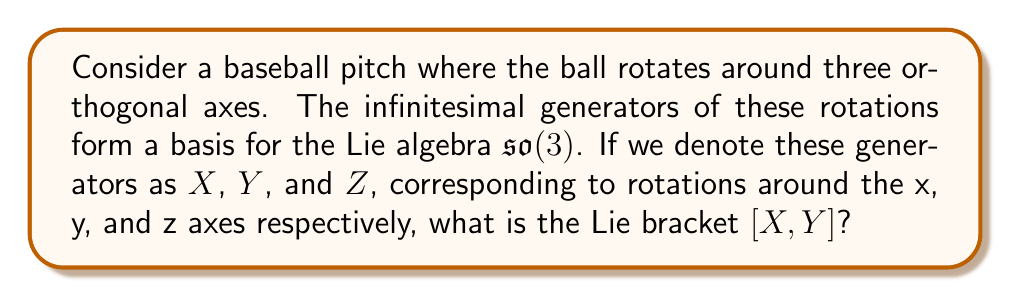Could you help me with this problem? Let's approach this step-by-step:

1) First, recall that for $\mathfrak{so}(3)$, the Lie algebra of 3D rotations, the generators are:

   $$X = \begin{pmatrix}
   0 & 0 & 0 \\
   0 & 0 & -1 \\
   0 & 1 & 0
   \end{pmatrix}, 
   Y = \begin{pmatrix}
   0 & 0 & 1 \\
   0 & 0 & 0 \\
   -1 & 0 & 0
   \end{pmatrix}, 
   Z = \begin{pmatrix}
   0 & -1 & 0 \\
   1 & 0 & 0 \\
   0 & 0 & 0
   \end{pmatrix}$$

2) The Lie bracket $[X,Y]$ is defined as $XY - YX$.

3) Let's compute $XY$:
   $$XY = \begin{pmatrix}
   0 & 0 & 0 \\
   0 & 0 & -1 \\
   0 & 1 & 0
   \end{pmatrix}
   \begin{pmatrix}
   0 & 0 & 1 \\
   0 & 0 & 0 \\
   -1 & 0 & 0
   \end{pmatrix} = 
   \begin{pmatrix}
   0 & 0 & 0 \\
   1 & 0 & 0 \\
   0 & 0 & 1
   \end{pmatrix}$$

4) Now let's compute $YX$:
   $$YX = \begin{pmatrix}
   0 & 0 & 1 \\
   0 & 0 & 0 \\
   -1 & 0 & 0
   \end{pmatrix}
   \begin{pmatrix}
   0 & 0 & 0 \\
   0 & 0 & -1 \\
   0 & 1 & 0
   \end{pmatrix} = 
   \begin{pmatrix}
   0 & 1 & 0 \\
   0 & 0 & 0 \\
   0 & 0 & 0
   \end{pmatrix}$$

5) Now we can compute $[X,Y] = XY - YX$:
   $$[X,Y] = \begin{pmatrix}
   0 & 0 & 0 \\
   1 & 0 & 0 \\
   0 & 0 & 1
   \end{pmatrix} - 
   \begin{pmatrix}
   0 & 1 & 0 \\
   0 & 0 & 0 \\
   0 & 0 & 0
   \end{pmatrix} = 
   \begin{pmatrix}
   0 & -1 & 0 \\
   1 & 0 & 0 \\
   0 & 0 & 1
   \end{pmatrix}$$

6) Comparing this result with the generator $Z$, we see that $[X,Y] = Z$.

This result is consistent with the cyclic property of the Lie brackets in $\mathfrak{so}(3)$: $[X,Y] = Z$, $[Y,Z] = X$, and $[Z,X] = Y$.
Answer: $[X,Y] = Z$ 